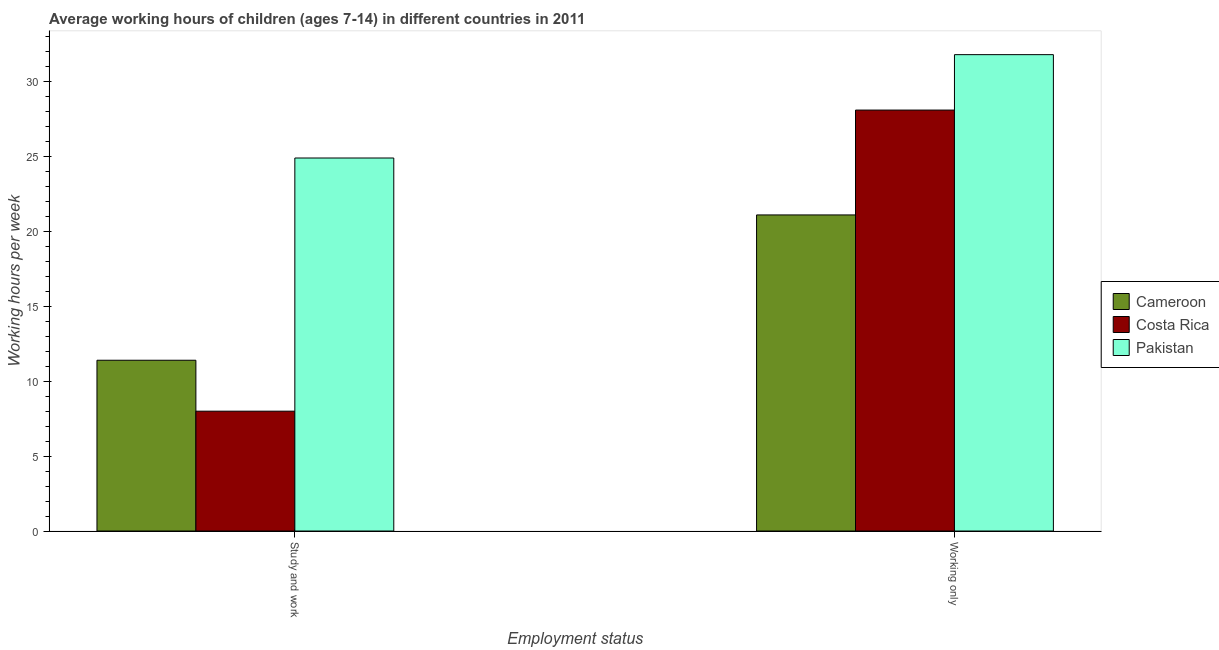How many different coloured bars are there?
Offer a very short reply. 3. How many groups of bars are there?
Ensure brevity in your answer.  2. How many bars are there on the 1st tick from the left?
Your answer should be very brief. 3. How many bars are there on the 2nd tick from the right?
Give a very brief answer. 3. What is the label of the 1st group of bars from the left?
Keep it short and to the point. Study and work. What is the average working hour of children involved in only work in Pakistan?
Make the answer very short. 31.8. Across all countries, what is the maximum average working hour of children involved in study and work?
Your answer should be compact. 24.9. Across all countries, what is the minimum average working hour of children involved in study and work?
Provide a succinct answer. 8. In which country was the average working hour of children involved in study and work minimum?
Offer a terse response. Costa Rica. What is the total average working hour of children involved in only work in the graph?
Your response must be concise. 81. What is the difference between the average working hour of children involved in study and work in Cameroon and that in Costa Rica?
Your answer should be very brief. 3.4. What is the difference between the average working hour of children involved in study and work in Pakistan and the average working hour of children involved in only work in Cameroon?
Your answer should be compact. 3.8. What is the difference between the average working hour of children involved in only work and average working hour of children involved in study and work in Costa Rica?
Your response must be concise. 20.1. What is the ratio of the average working hour of children involved in study and work in Costa Rica to that in Pakistan?
Give a very brief answer. 0.32. What does the 2nd bar from the right in Study and work represents?
Ensure brevity in your answer.  Costa Rica. Are all the bars in the graph horizontal?
Offer a very short reply. No. What is the difference between two consecutive major ticks on the Y-axis?
Your answer should be compact. 5. Are the values on the major ticks of Y-axis written in scientific E-notation?
Your answer should be very brief. No. Where does the legend appear in the graph?
Ensure brevity in your answer.  Center right. How many legend labels are there?
Keep it short and to the point. 3. What is the title of the graph?
Your response must be concise. Average working hours of children (ages 7-14) in different countries in 2011. Does "Curacao" appear as one of the legend labels in the graph?
Offer a very short reply. No. What is the label or title of the X-axis?
Your response must be concise. Employment status. What is the label or title of the Y-axis?
Provide a succinct answer. Working hours per week. What is the Working hours per week of Cameroon in Study and work?
Provide a succinct answer. 11.4. What is the Working hours per week of Costa Rica in Study and work?
Ensure brevity in your answer.  8. What is the Working hours per week of Pakistan in Study and work?
Offer a terse response. 24.9. What is the Working hours per week in Cameroon in Working only?
Give a very brief answer. 21.1. What is the Working hours per week in Costa Rica in Working only?
Give a very brief answer. 28.1. What is the Working hours per week of Pakistan in Working only?
Your answer should be very brief. 31.8. Across all Employment status, what is the maximum Working hours per week in Cameroon?
Your answer should be very brief. 21.1. Across all Employment status, what is the maximum Working hours per week in Costa Rica?
Ensure brevity in your answer.  28.1. Across all Employment status, what is the maximum Working hours per week of Pakistan?
Your answer should be very brief. 31.8. Across all Employment status, what is the minimum Working hours per week of Cameroon?
Provide a short and direct response. 11.4. Across all Employment status, what is the minimum Working hours per week in Pakistan?
Offer a very short reply. 24.9. What is the total Working hours per week in Cameroon in the graph?
Offer a very short reply. 32.5. What is the total Working hours per week in Costa Rica in the graph?
Your answer should be compact. 36.1. What is the total Working hours per week of Pakistan in the graph?
Your answer should be very brief. 56.7. What is the difference between the Working hours per week in Cameroon in Study and work and that in Working only?
Provide a short and direct response. -9.7. What is the difference between the Working hours per week in Costa Rica in Study and work and that in Working only?
Your answer should be compact. -20.1. What is the difference between the Working hours per week of Cameroon in Study and work and the Working hours per week of Costa Rica in Working only?
Make the answer very short. -16.7. What is the difference between the Working hours per week of Cameroon in Study and work and the Working hours per week of Pakistan in Working only?
Your answer should be very brief. -20.4. What is the difference between the Working hours per week of Costa Rica in Study and work and the Working hours per week of Pakistan in Working only?
Provide a short and direct response. -23.8. What is the average Working hours per week in Cameroon per Employment status?
Offer a terse response. 16.25. What is the average Working hours per week of Costa Rica per Employment status?
Your response must be concise. 18.05. What is the average Working hours per week of Pakistan per Employment status?
Make the answer very short. 28.35. What is the difference between the Working hours per week in Cameroon and Working hours per week in Costa Rica in Study and work?
Keep it short and to the point. 3.4. What is the difference between the Working hours per week in Cameroon and Working hours per week in Pakistan in Study and work?
Provide a short and direct response. -13.5. What is the difference between the Working hours per week in Costa Rica and Working hours per week in Pakistan in Study and work?
Provide a succinct answer. -16.9. What is the difference between the Working hours per week of Cameroon and Working hours per week of Costa Rica in Working only?
Your response must be concise. -7. What is the difference between the Working hours per week in Cameroon and Working hours per week in Pakistan in Working only?
Make the answer very short. -10.7. What is the ratio of the Working hours per week in Cameroon in Study and work to that in Working only?
Offer a very short reply. 0.54. What is the ratio of the Working hours per week of Costa Rica in Study and work to that in Working only?
Offer a terse response. 0.28. What is the ratio of the Working hours per week of Pakistan in Study and work to that in Working only?
Offer a terse response. 0.78. What is the difference between the highest and the second highest Working hours per week of Cameroon?
Provide a short and direct response. 9.7. What is the difference between the highest and the second highest Working hours per week in Costa Rica?
Give a very brief answer. 20.1. What is the difference between the highest and the second highest Working hours per week in Pakistan?
Your answer should be compact. 6.9. What is the difference between the highest and the lowest Working hours per week in Cameroon?
Give a very brief answer. 9.7. What is the difference between the highest and the lowest Working hours per week of Costa Rica?
Provide a short and direct response. 20.1. 